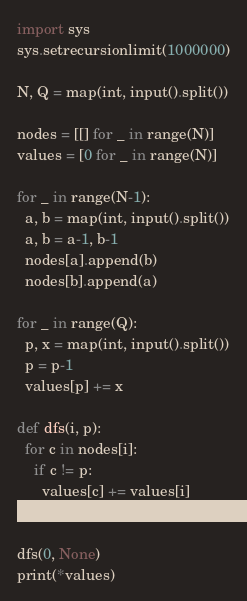<code> <loc_0><loc_0><loc_500><loc_500><_Python_>import sys
sys.setrecursionlimit(1000000)

N, Q = map(int, input().split())

nodes = [[] for _ in range(N)]
values = [0 for _ in range(N)]

for _ in range(N-1):
  a, b = map(int, input().split())
  a, b = a-1, b-1
  nodes[a].append(b)
  nodes[b].append(a)

for _ in range(Q):
  p, x = map(int, input().split())
  p = p-1
  values[p] += x

def dfs(i, p):
  for c in nodes[i]:
    if c != p:
      values[c] += values[i]
      dfs(c, i)

dfs(0, None)
print(*values)
</code> 